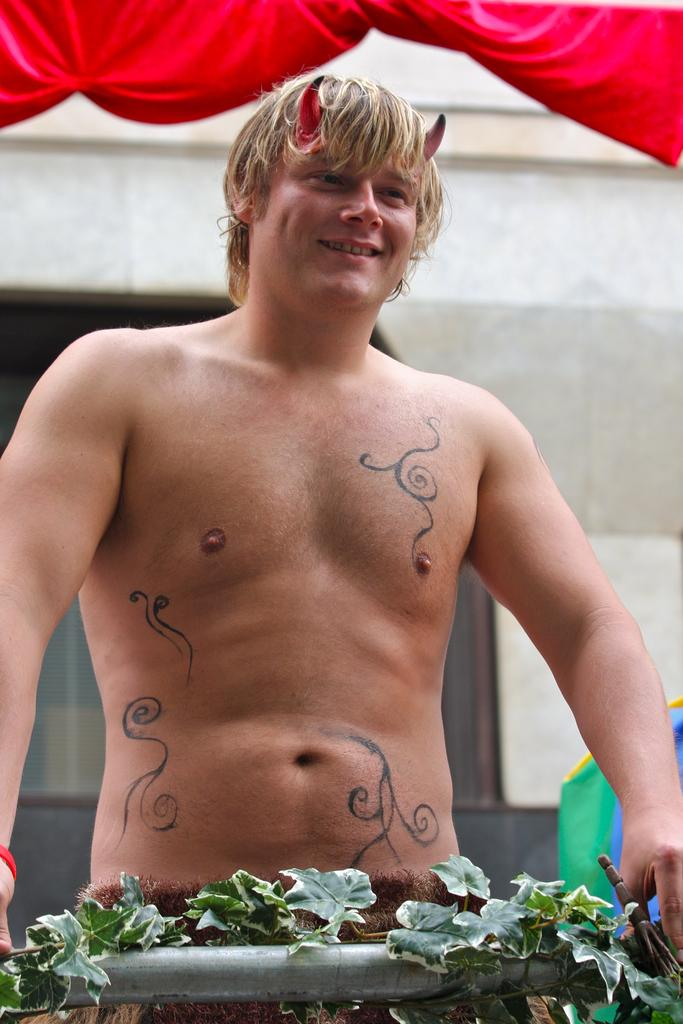What can be seen in the foreground of the image? In the foreground of the image, there are leaves and an iron pole, as well as a person. What is present in the background of the image? In the background of the image, there is a curtain and a wall. Can you describe the person in the foreground of the image? Unfortunately, the image does not provide enough detail to describe the person. What type of stove can be seen in the image? There is no stove present in the image. How does the presence of giants affect the scene in the image? There are no giants present in the image, so their presence would not affect the scene. 